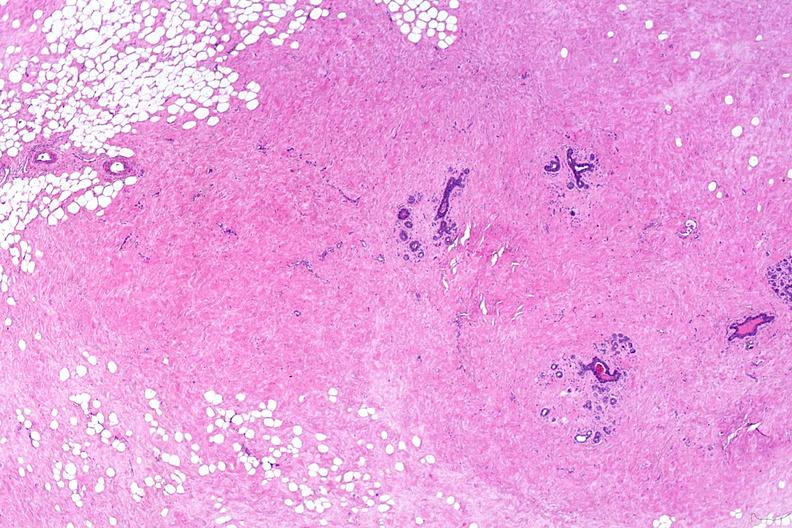does this image show normal breast?
Answer the question using a single word or phrase. Yes 